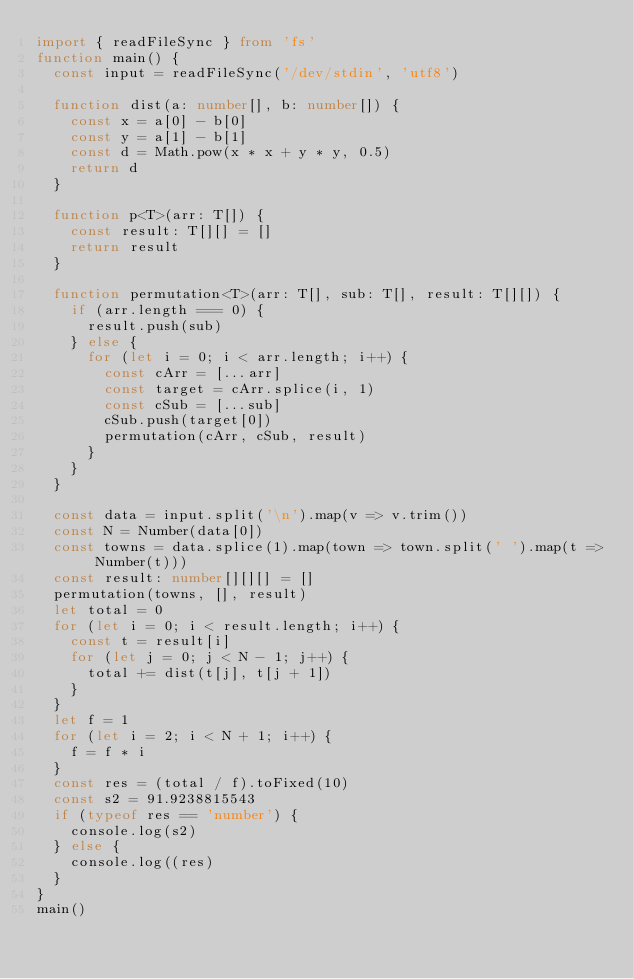<code> <loc_0><loc_0><loc_500><loc_500><_TypeScript_>import { readFileSync } from 'fs'
function main() {
	const input = readFileSync('/dev/stdin', 'utf8')

  function dist(a: number[], b: number[]) {
    const x = a[0] - b[0]
    const y = a[1] - b[1]
    const d = Math.pow(x * x + y * y, 0.5)
    return d
  }

  function p<T>(arr: T[]) {
    const result: T[][] = []
    return result
  }

  function permutation<T>(arr: T[], sub: T[], result: T[][]) {
    if (arr.length === 0) {
      result.push(sub)
    } else {
      for (let i = 0; i < arr.length; i++) {
        const cArr = [...arr]
        const target = cArr.splice(i, 1)
        const cSub = [...sub]
        cSub.push(target[0])
        permutation(cArr, cSub, result)        
      }
    }
  }

  const data = input.split('\n').map(v => v.trim())
  const N = Number(data[0])
  const towns = data.splice(1).map(town => town.split(' ').map(t => Number(t)))
  const result: number[][][] = []
  permutation(towns, [], result)
  let total = 0
  for (let i = 0; i < result.length; i++) {
    const t = result[i]
    for (let j = 0; j < N - 1; j++) {
      total += dist(t[j], t[j + 1])      
    }
  }
  let f = 1
  for (let i = 2; i < N + 1; i++) {
    f = f * i
  }
  const res = (total / f).toFixed(10)
  const s2 = 91.9238815543
  if (typeof res == 'number') {
    console.log(s2)
  } else {
    console.log((res)
  }
}
main()
</code> 